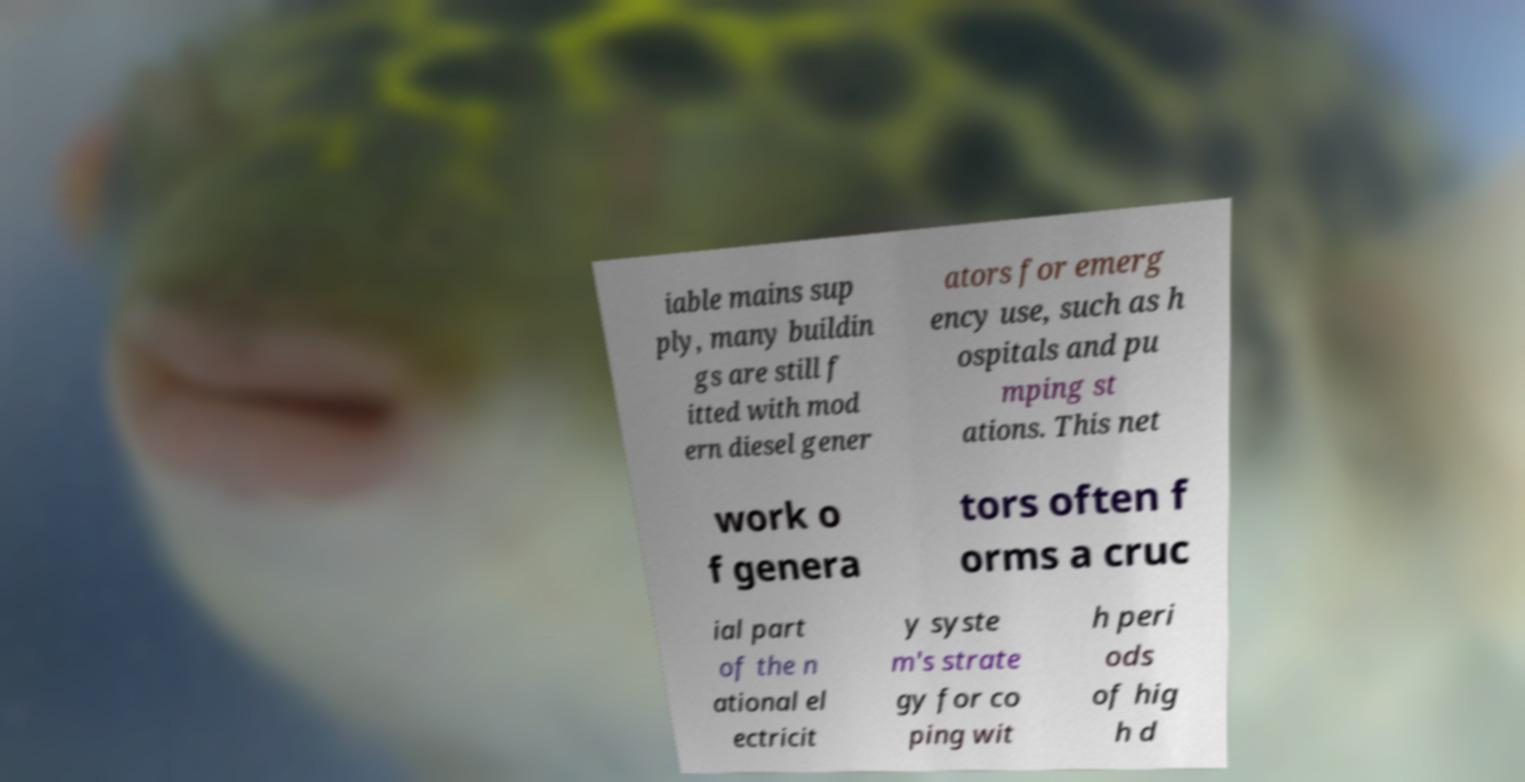Please read and relay the text visible in this image. What does it say? iable mains sup ply, many buildin gs are still f itted with mod ern diesel gener ators for emerg ency use, such as h ospitals and pu mping st ations. This net work o f genera tors often f orms a cruc ial part of the n ational el ectricit y syste m's strate gy for co ping wit h peri ods of hig h d 